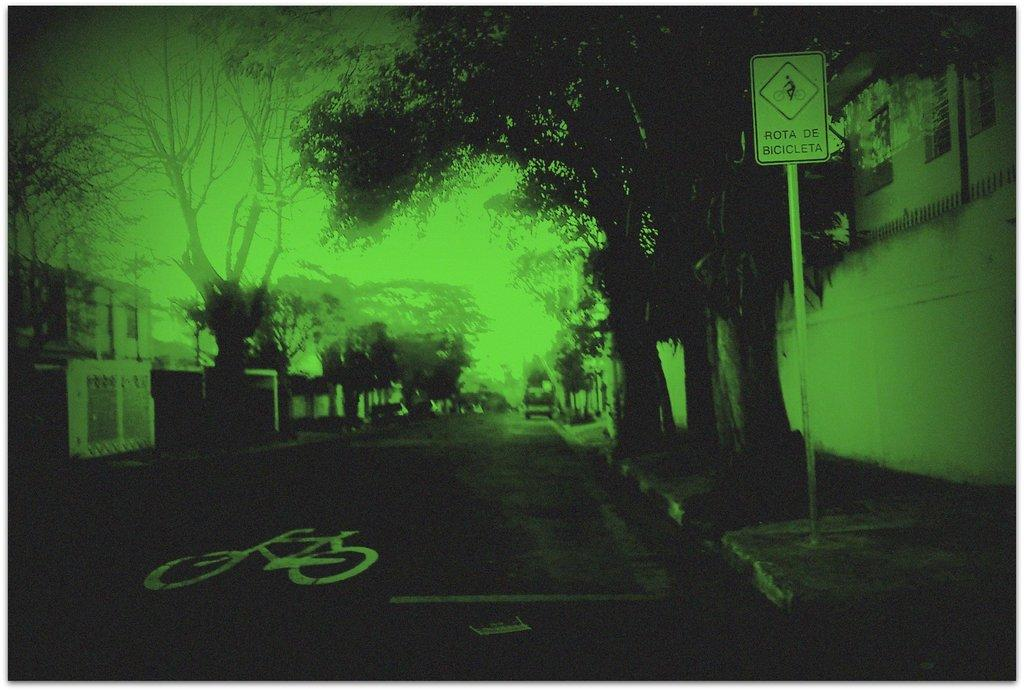What is the main feature of the image? There is a road in the image. What can be seen on the sides of the road? There are trees on the sides of the road. What structure is present in the image? There is a sign board with a pole in the image. What other element can be seen in the image? There is a wall in the image. How would you describe the overall color of the image? The image appears to be green. Can you tell me how many berries are on the office desk in the image? There is no office desk or berries present in the image. What type of eggs can be seen in the image? There are no eggs present in the image. 